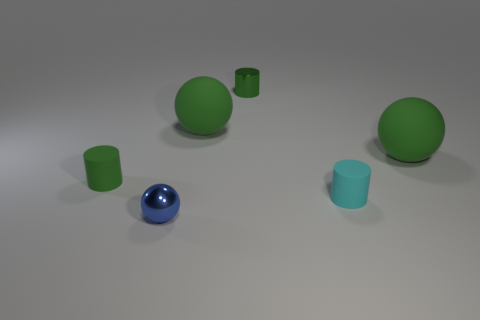Add 1 big green objects. How many objects exist? 7 Subtract all tiny cyan rubber cylinders. How many cylinders are left? 2 Subtract all green spheres. How many spheres are left? 1 Subtract 1 spheres. How many spheres are left? 2 Subtract all large spheres. Subtract all tiny green shiny objects. How many objects are left? 3 Add 4 small green rubber cylinders. How many small green rubber cylinders are left? 5 Add 1 blue things. How many blue things exist? 2 Subtract 0 purple spheres. How many objects are left? 6 Subtract all cyan balls. Subtract all red blocks. How many balls are left? 3 Subtract all yellow blocks. How many green cylinders are left? 2 